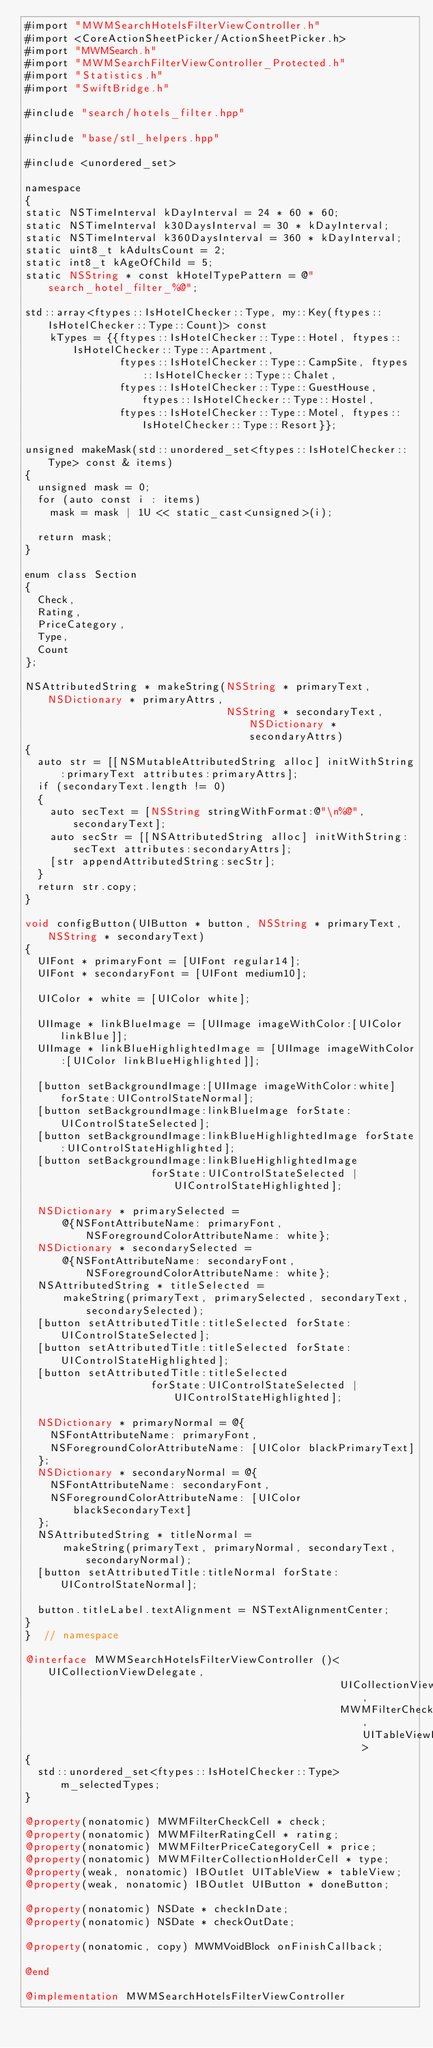<code> <loc_0><loc_0><loc_500><loc_500><_ObjectiveC_>#import "MWMSearchHotelsFilterViewController.h"
#import <CoreActionSheetPicker/ActionSheetPicker.h>
#import "MWMSearch.h"
#import "MWMSearchFilterViewController_Protected.h"
#import "Statistics.h"
#import "SwiftBridge.h"

#include "search/hotels_filter.hpp"

#include "base/stl_helpers.hpp"

#include <unordered_set>

namespace
{
static NSTimeInterval kDayInterval = 24 * 60 * 60;
static NSTimeInterval k30DaysInterval = 30 * kDayInterval;
static NSTimeInterval k360DaysInterval = 360 * kDayInterval;
static uint8_t kAdultsCount = 2;
static int8_t kAgeOfChild = 5;
static NSString * const kHotelTypePattern = @"search_hotel_filter_%@";

std::array<ftypes::IsHotelChecker::Type, my::Key(ftypes::IsHotelChecker::Type::Count)> const
    kTypes = {{ftypes::IsHotelChecker::Type::Hotel, ftypes::IsHotelChecker::Type::Apartment,
               ftypes::IsHotelChecker::Type::CampSite, ftypes::IsHotelChecker::Type::Chalet,
               ftypes::IsHotelChecker::Type::GuestHouse, ftypes::IsHotelChecker::Type::Hostel,
               ftypes::IsHotelChecker::Type::Motel, ftypes::IsHotelChecker::Type::Resort}};

unsigned makeMask(std::unordered_set<ftypes::IsHotelChecker::Type> const & items)
{
  unsigned mask = 0;
  for (auto const i : items)
    mask = mask | 1U << static_cast<unsigned>(i);

  return mask;
}

enum class Section
{
  Check,
  Rating,
  PriceCategory,
  Type,
  Count
};

NSAttributedString * makeString(NSString * primaryText, NSDictionary * primaryAttrs,
                                NSString * secondaryText, NSDictionary * secondaryAttrs)
{
  auto str = [[NSMutableAttributedString alloc] initWithString:primaryText attributes:primaryAttrs];
  if (secondaryText.length != 0)
  {
    auto secText = [NSString stringWithFormat:@"\n%@", secondaryText];
    auto secStr = [[NSAttributedString alloc] initWithString:secText attributes:secondaryAttrs];
    [str appendAttributedString:secStr];
  }
  return str.copy;
}

void configButton(UIButton * button, NSString * primaryText, NSString * secondaryText)
{
  UIFont * primaryFont = [UIFont regular14];
  UIFont * secondaryFont = [UIFont medium10];

  UIColor * white = [UIColor white];

  UIImage * linkBlueImage = [UIImage imageWithColor:[UIColor linkBlue]];
  UIImage * linkBlueHighlightedImage = [UIImage imageWithColor:[UIColor linkBlueHighlighted]];

  [button setBackgroundImage:[UIImage imageWithColor:white] forState:UIControlStateNormal];
  [button setBackgroundImage:linkBlueImage forState:UIControlStateSelected];
  [button setBackgroundImage:linkBlueHighlightedImage forState:UIControlStateHighlighted];
  [button setBackgroundImage:linkBlueHighlightedImage
                    forState:UIControlStateSelected | UIControlStateHighlighted];

  NSDictionary * primarySelected =
      @{NSFontAttributeName: primaryFont, NSForegroundColorAttributeName: white};
  NSDictionary * secondarySelected =
      @{NSFontAttributeName: secondaryFont, NSForegroundColorAttributeName: white};
  NSAttributedString * titleSelected =
      makeString(primaryText, primarySelected, secondaryText, secondarySelected);
  [button setAttributedTitle:titleSelected forState:UIControlStateSelected];
  [button setAttributedTitle:titleSelected forState:UIControlStateHighlighted];
  [button setAttributedTitle:titleSelected
                    forState:UIControlStateSelected | UIControlStateHighlighted];

  NSDictionary * primaryNormal = @{
    NSFontAttributeName: primaryFont,
    NSForegroundColorAttributeName: [UIColor blackPrimaryText]
  };
  NSDictionary * secondaryNormal = @{
    NSFontAttributeName: secondaryFont,
    NSForegroundColorAttributeName: [UIColor blackSecondaryText]
  };
  NSAttributedString * titleNormal =
      makeString(primaryText, primaryNormal, secondaryText, secondaryNormal);
  [button setAttributedTitle:titleNormal forState:UIControlStateNormal];

  button.titleLabel.textAlignment = NSTextAlignmentCenter;
}
}  // namespace

@interface MWMSearchHotelsFilterViewController ()<UICollectionViewDelegate,
                                                  UICollectionViewDataSource,
                                                  MWMFilterCheckCellDelegate, UITableViewDataSource>
{
  std::unordered_set<ftypes::IsHotelChecker::Type> m_selectedTypes;
}

@property(nonatomic) MWMFilterCheckCell * check;
@property(nonatomic) MWMFilterRatingCell * rating;
@property(nonatomic) MWMFilterPriceCategoryCell * price;
@property(nonatomic) MWMFilterCollectionHolderCell * type;
@property(weak, nonatomic) IBOutlet UITableView * tableView;
@property(weak, nonatomic) IBOutlet UIButton * doneButton;

@property(nonatomic) NSDate * checkInDate;
@property(nonatomic) NSDate * checkOutDate;

@property(nonatomic, copy) MWMVoidBlock onFinishCallback;

@end

@implementation MWMSearchHotelsFilterViewController
</code> 